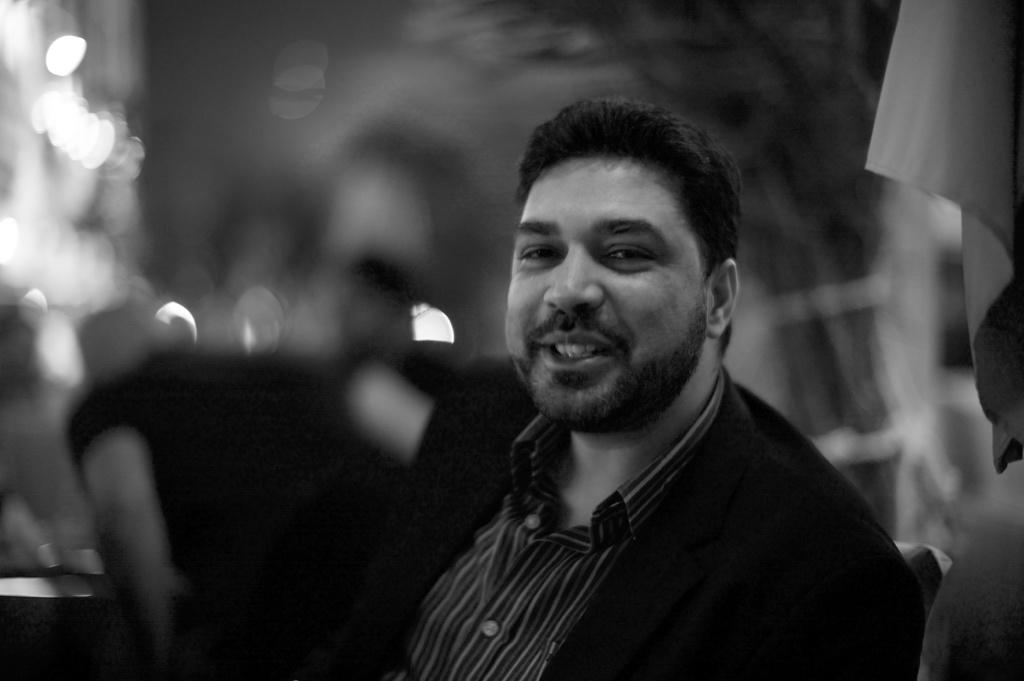What is the main subject of the image? There is a person in the image. What is the person wearing? The person is wearing a black suit. What is the person's facial expression? The person is smiling. Can you describe the background of the image? The background of the image is blurred. What is present in the top right corner of the image? There is a cloth in the top right corner of the image. What type of cup can be seen in the person's hand in the image? There is no cup present in the person's hand or anywhere else in the image. 